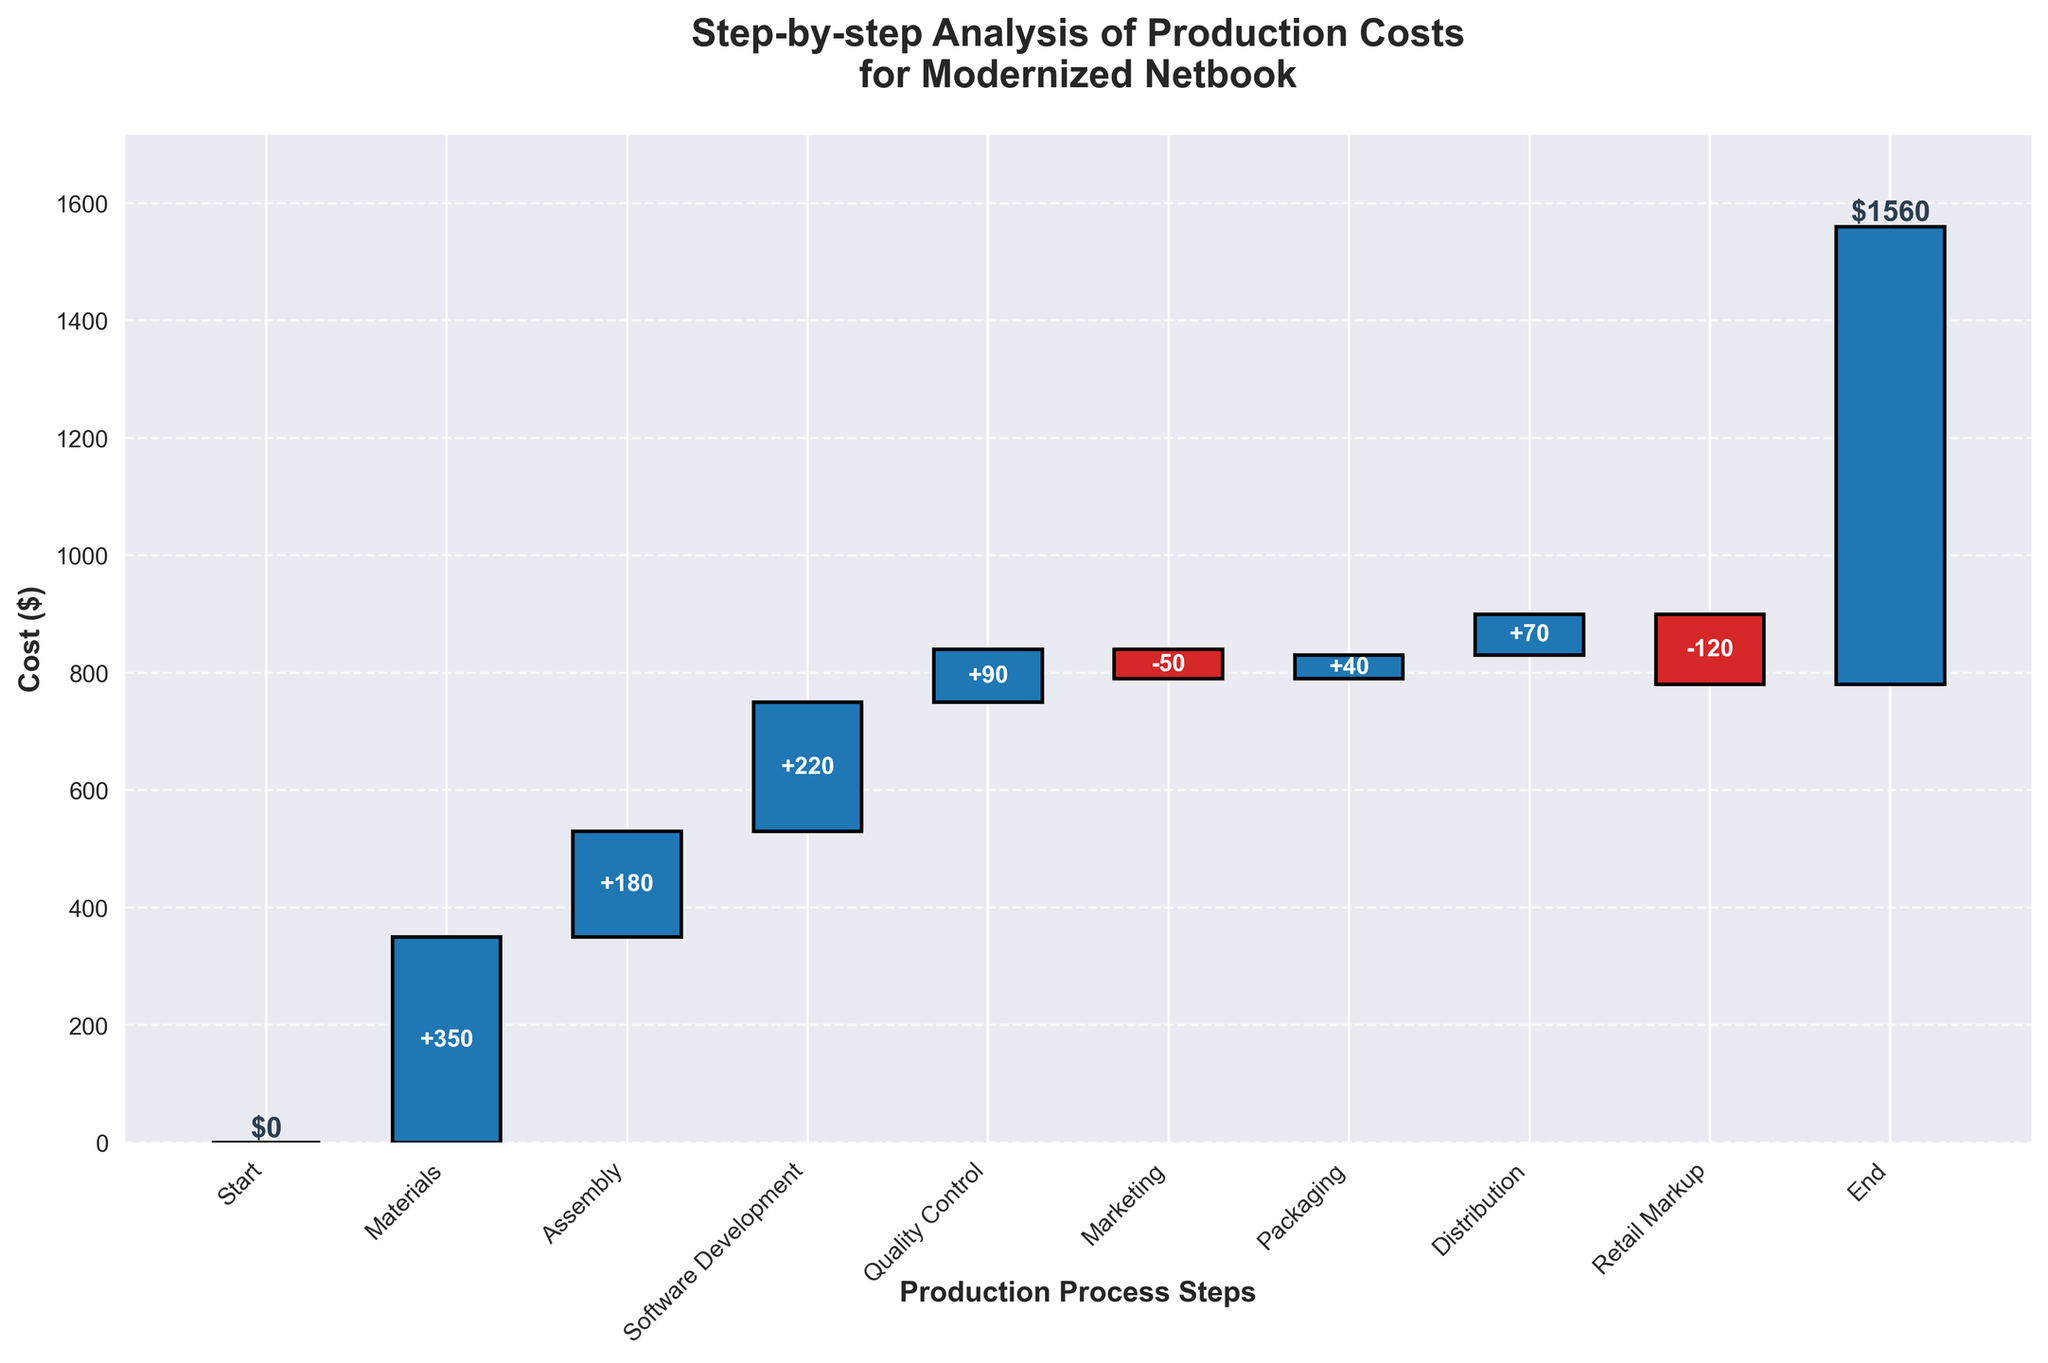What's the title of the chart? The title of the chart is written at the top and reads "Step-by-step Analysis of Production Costs for Modernized Netbook".
Answer: Step-by-step Analysis of Production Costs for Modernized Netbook How much does the "Materials" step add to the cost? The "Materials" step is the second bar in the chart and it adds $350.
Answer: $350 What color represents a cost addition and a cost reduction? Cost addition bars are shown in blue, while cost reduction bars are shown in red.
Answer: Blue for addition, Red for reduction What is the cumulative cost after the "Assembly" step? The cumulative cost after the "Assembly" step is the sum of "Materials" and "Assembly". So, it's $350 + $180 = $530.
Answer: $530 What are the steps that involve a reduction in cost? By checking the colors, we see that "Marketing" and "Retail Markup", represented in red, are the steps that involve a reduction in cost.
Answer: Marketing and Retail Markup What is the cumulative cost before the "Retail Markup" step? The cumulative cost before "Retail Markup" is the sum of all steps before it: $350 (Materials) + $180 (Assembly) + $220 (Software Development) + $90 (Quality Control) - $50 (Marketing) + $40 (Packaging) + $70 (Distribution) = $900.
Answer: $900 Which steps increase the production cost by more than $100? The steps with values greater than $100 in the positive direction are "Materials", "Assembly", and "Software Development".
Answer: Materials, Assembly, and Software Development How does the cost of "Packaging" compare to "Marketing"? "Packaging" adds $40 to the cost, while "Marketing" reduces the cost by $50. Therefore, "Packaging" increases the cost while "Marketing" reduces it.
Answer: Packaging increases, Marketing reduces What is the final production cost of the modernized netbook after all steps? The final production cost after all steps is labeled as "End" and is $780.
Answer: $780 What is the difference in cost added by "Quality Control" and "Distribution"? The cost added by "Quality Control" is $90 and by "Distribution" is $70. The difference is $90 - $70 = $20.
Answer: $20 